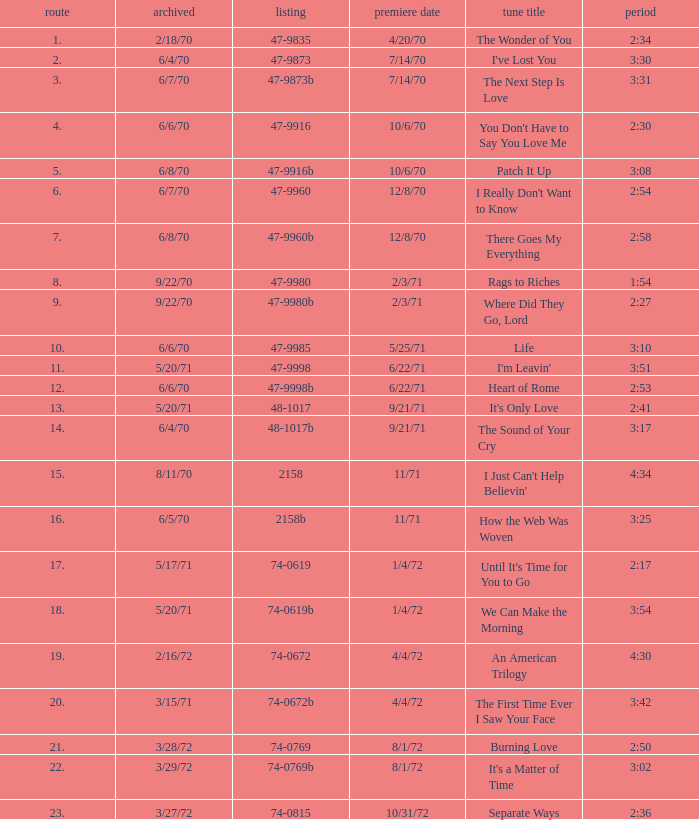What is the catalogue number for the song that is 3:17 and was released 9/21/71? 48-1017b. 